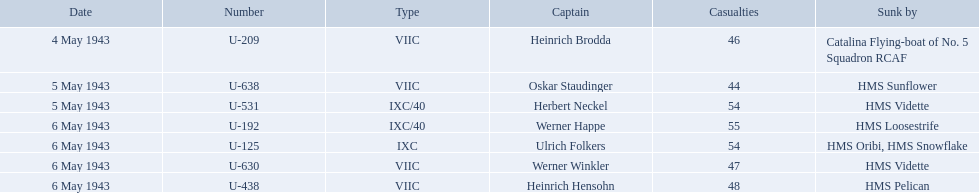Who are the captains of the u boats? Heinrich Brodda, Oskar Staudinger, Herbert Neckel, Werner Happe, Ulrich Folkers, Werner Winkler, Heinrich Hensohn. What are the dates the u boat captains were lost? 4 May 1943, 5 May 1943, 5 May 1943, 6 May 1943, 6 May 1943, 6 May 1943, 6 May 1943. Of these, which were lost on may 5? Oskar Staudinger, Herbert Neckel. Other than oskar staudinger, who else was lost on this day? Herbert Neckel. What is the list of ships under sunk by? Catalina Flying-boat of No. 5 Squadron RCAF, HMS Sunflower, HMS Vidette, HMS Loosestrife, HMS Oribi, HMS Snowflake, HMS Vidette, HMS Pelican. Which captains did hms pelican sink? Heinrich Hensohn. Which were the names of the sinkers of the convoys? Catalina Flying-boat of No. 5 Squadron RCAF, HMS Sunflower, HMS Vidette, HMS Loosestrife, HMS Oribi, HMS Snowflake, HMS Vidette, HMS Pelican. What captain was sunk by the hms pelican? Heinrich Hensohn. Parse the table in full. {'header': ['Date', 'Number', 'Type', 'Captain', 'Casualties', 'Sunk by'], 'rows': [['4 May 1943', 'U-209', 'VIIC', 'Heinrich Brodda', '46', 'Catalina Flying-boat of No. 5 Squadron RCAF'], ['5 May 1943', 'U-638', 'VIIC', 'Oskar Staudinger', '44', 'HMS Sunflower'], ['5 May 1943', 'U-531', 'IXC/40', 'Herbert Neckel', '54', 'HMS Vidette'], ['6 May 1943', 'U-192', 'IXC/40', 'Werner Happe', '55', 'HMS Loosestrife'], ['6 May 1943', 'U-125', 'IXC', 'Ulrich Folkers', '54', 'HMS Oribi, HMS Snowflake'], ['6 May 1943', 'U-630', 'VIIC', 'Werner Winkler', '47', 'HMS Vidette'], ['6 May 1943', 'U-438', 'VIIC', 'Heinrich Hensohn', '48', 'HMS Pelican']]} Who were the heads in the ons 5 convoy? Heinrich Brodda, Oskar Staudinger, Herbert Neckel, Werner Happe, Ulrich Folkers, Werner Winkler, Heinrich Hensohn. Which ones faced u-boat losses on may 5? Oskar Staudinger, Herbert Neckel. Apart from oskar staudinger, who else is in this list? Herbert Neckel. What were the monikers of those who sank the convoys? Catalina Flying-boat of No. 5 Squadron RCAF, HMS Sunflower, HMS Vidette, HMS Loosestrife, HMS Oribi, HMS Snowflake, HMS Vidette, HMS Pelican. Which skipper was brought down by the hms pelican? Heinrich Hensohn. What is the enumeration of vessels sunk by? Catalina Flying-boat of No. 5 Squadron RCAF, HMS Sunflower, HMS Vidette, HMS Loosestrife, HMS Oribi, HMS Snowflake, HMS Vidette, HMS Pelican. Which commanders did hms pelican submerge? Heinrich Hensohn. Who were the leaders of the u-boats? Heinrich Brodda, Oskar Staudinger, Herbert Neckel, Werner Happe, Ulrich Folkers, Werner Winkler, Heinrich Hensohn. On which dates did the u-boat captains vanish? 4 May 1943, 5 May 1943, 5 May 1943, 6 May 1943, 6 May 1943, 6 May 1943, 6 May 1943. Which of them were lost on may 5th? Oskar Staudinger, Herbert Neckel. Excluding oskar staudinger, who else was lost on this date? Herbert Neckel. Who are all the captains? Heinrich Brodda, Oskar Staudinger, Herbert Neckel, Werner Happe, Ulrich Folkers, Werner Winkler, Heinrich Hensohn. What caused the sinking of each captain? Catalina Flying-boat of No. 5 Squadron RCAF, HMS Sunflower, HMS Vidette, HMS Loosestrife, HMS Oribi, HMS Snowflake, HMS Vidette, HMS Pelican. Which one was sunk by the hms pelican? Heinrich Hensohn. Can you list all the captains? Heinrich Brodda, Oskar Staudinger, Herbert Neckel, Werner Happe, Ulrich Folkers, Werner Winkler, Heinrich Hensohn. What led to the sinking of each captain? Catalina Flying-boat of No. 5 Squadron RCAF, HMS Sunflower, HMS Vidette, HMS Loosestrife, HMS Oribi, HMS Snowflake, HMS Vidette, HMS Pelican. Who was sunk by the hms pelican? Heinrich Hensohn. 